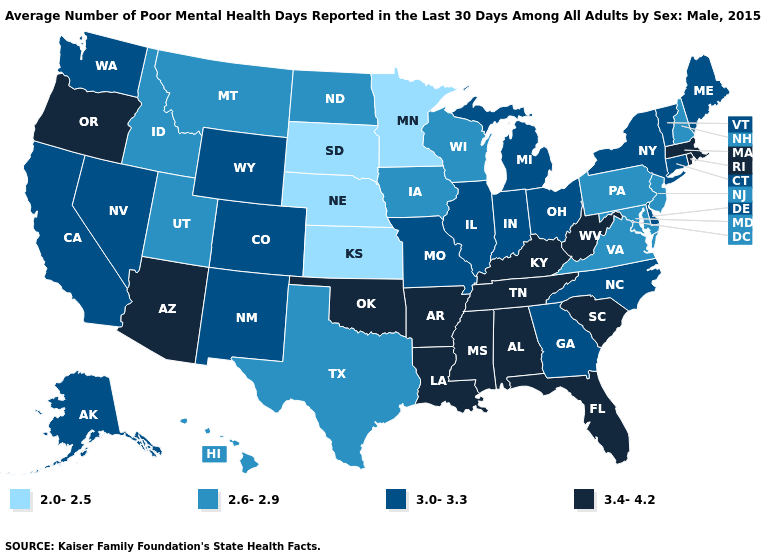What is the lowest value in the South?
Give a very brief answer. 2.6-2.9. Name the states that have a value in the range 2.0-2.5?
Be succinct. Kansas, Minnesota, Nebraska, South Dakota. What is the highest value in the USA?
Write a very short answer. 3.4-4.2. How many symbols are there in the legend?
Keep it brief. 4. Which states have the lowest value in the Northeast?
Write a very short answer. New Hampshire, New Jersey, Pennsylvania. Name the states that have a value in the range 2.0-2.5?
Answer briefly. Kansas, Minnesota, Nebraska, South Dakota. Does the map have missing data?
Keep it brief. No. Does Texas have the lowest value in the South?
Concise answer only. Yes. What is the lowest value in the MidWest?
Keep it brief. 2.0-2.5. What is the value of Maine?
Keep it brief. 3.0-3.3. Among the states that border Florida , does Georgia have the highest value?
Quick response, please. No. Which states have the lowest value in the USA?
Keep it brief. Kansas, Minnesota, Nebraska, South Dakota. Among the states that border Montana , which have the lowest value?
Keep it brief. South Dakota. What is the highest value in the MidWest ?
Write a very short answer. 3.0-3.3. Does Kansas have the lowest value in the USA?
Be succinct. Yes. 